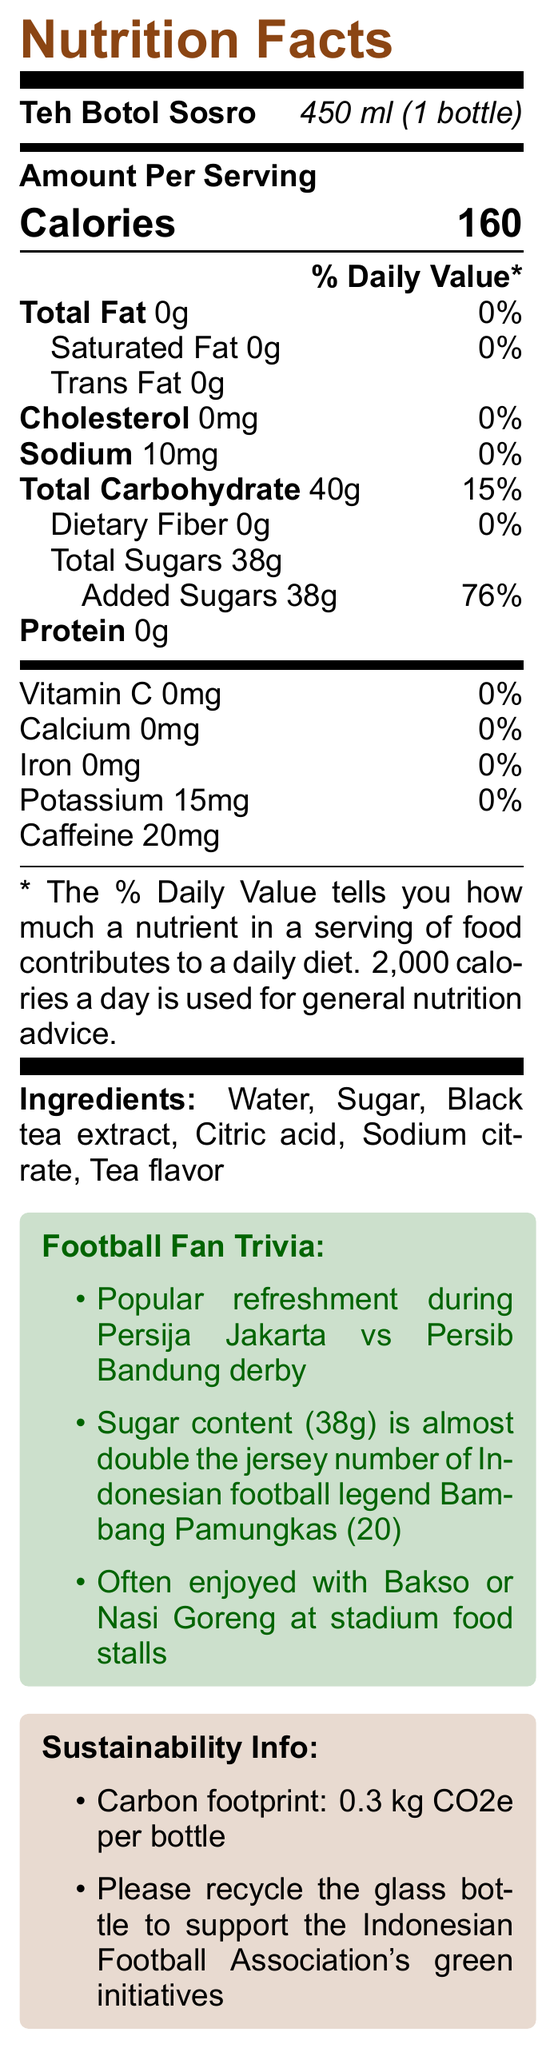how many servings are there in one container of Teh Botol Sosro? The document states there is one serving per container.
Answer: 1 what is the calorie content per serving of Teh Botol Sosro? The document lists that one serving, which is 450 ml, contains 160 calories.
Answer: 160 calories how many grams of sugar does Teh Botol Sosro contain? Under the Total Sugars heading, the document specifies 38 grams.
Answer: 38 grams does Teh Botol Sosro contain any dietary fiber? The document indicates that total dietary fiber is 0 grams.
Answer: No what is the main ingredient in Teh Botol Sosro? The ingredients list shows Water as the first ingredient, indicating it is the main ingredient.
Answer: Water what percentage of daily value is the sodium content in Teh Botol Sosro? The document mentions that the sodium content is 10mg and is 0% of the daily value.
Answer: 0% how much caffeine does Teh Botol Sosro contain per serving? The document states that the caffeine content per serving is 20mg.
Answer: 20 mg how is the sugar content of Teh Botol Sosro compared to Bambang Pamungkas' jersey number? A. Less B. Equal C. Almost double D. More than double The document's trivia section notes that the sugar content (38g) is almost double the jersey number of Indonesian football legend Bambang Pamungkas (20).
Answer: C what item is not typically paired with Teh Botol Sosro? A. Bakso B. Nasi Goreng C. Sate D. Sandwich Sandwich is not mentioned in the food pairings; Bakso and Nasi Goreng are typical pairings mentioned in the document.
Answer: D is the carbon footprint information relevant to the promotion of Teh Botol? Yes, the document highlights sustainability information including the carbon footprint and recycling information, which is relevant to environmental promotions.
Answer: Yes briefly summarize the main points of the Teh Botol Sosro Nutrition Facts label. The main points include Teh Botol Sosro's nutrition details focusing on calories and sugar content, its cultural relevance during football matches, food pairings, and sustainability information.
Answer: Teh Botol Sosro is a popular Indonesian iced tea with 160 calories and 38 grams of sugar per 450 ml serving. It has no fat, dietary fiber, or protein. The beverage is particularly enjoyed during football matches and has cultural significance. The product also emphasizes sustainability by highlighting its low carbon footprint and encouragement to recycle the glass bottle. how many milligrams of Vitamin C does Teh Botol Sosro contain? The nutrition label lists Vitamin C as 0 mg.
Answer: 0 mg what is the percentage of the daily value for added sugars in Teh Botol Sosro? The document states that added sugars make up 76% of the daily value.
Answer: 76% what is the total carbohydrate content in one serving of Teh Botol Sosro? The document indicates that the total carbohydrate content per serving is 40 grams.
Answer: 40 grams what is the cholesterol content in Teh Botol Sosro? The document notes that there is no cholesterol in Teh Botol Sosro.
Answer: 0 mg which ingredient makes up the flavor profile of Teh Botol Sosro alongside black tea extract? A. Sodium citrate B. Tea flavor C. Citric acid D. Potassium Tea flavor is listed among the ingredients alongside black tea extract.
Answer: B is Teh Botol Sosro a good source of calcium? The document shows that the calcium content is 0 mg, indicating it is not a source of calcium.
Answer: No what is the total fat content of Teh Botol Sosro per serving? The total fat content is listed as 0 grams per serving.
Answer: 0 grams what percentage of daily value is the total carbohydrate content of Teh Botol Sosro? The document specifies that the total carbohydrate content makes up 15% of the daily value.
Answer: 15% how often is Teh Botol Sosro consumed during football matches? The document mentions it is popular during football matches but does not specify frequency.
Answer: Cannot be determined 